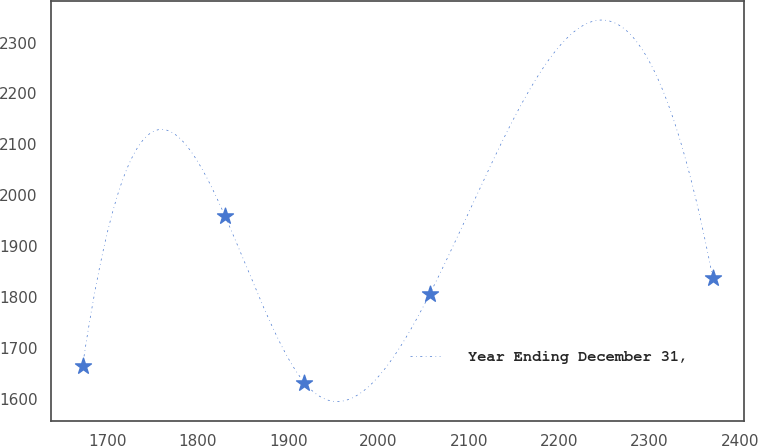<chart> <loc_0><loc_0><loc_500><loc_500><line_chart><ecel><fcel>Year Ending December 31,<nl><fcel>1672.41<fcel>1664.2<nl><fcel>1830.04<fcel>1959.19<nl><fcel>1918.03<fcel>1631.42<nl><fcel>2056.64<fcel>1805.03<nl><fcel>2370.01<fcel>1837.81<nl></chart> 